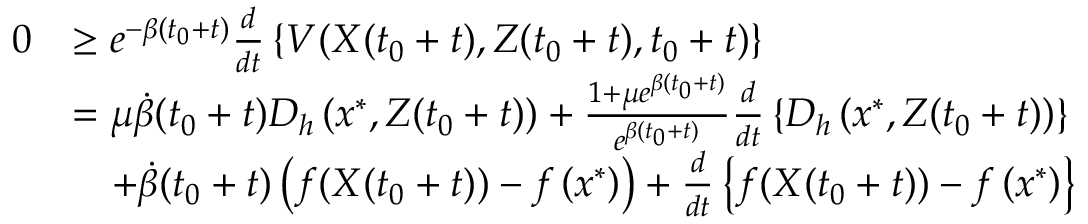<formula> <loc_0><loc_0><loc_500><loc_500>\begin{array} { r l } { 0 } & { \geq e ^ { - \beta ( t _ { 0 } + t ) } \frac { d } { d t } \left \{ V ( X ( t _ { 0 } + t ) , Z ( t _ { 0 } + t ) , t _ { 0 } + t ) \right \} } \\ & { = \mu \dot { \beta } ( t _ { 0 } + t ) D _ { h } \left ( x ^ { * } , Z ( t _ { 0 } + t ) \right ) + \frac { 1 + \mu e ^ { \beta ( t _ { 0 } + t ) } } { e ^ { \beta ( t _ { 0 } + t ) } } \frac { d } { d t } \left \{ D _ { h } \left ( x ^ { * } , Z ( t _ { 0 } + t ) \right ) \right \} } \\ & { \quad + \dot { \beta } ( t _ { 0 } + t ) \left ( f ( X ( t _ { 0 } + t ) ) - f \left ( x ^ { * } \right ) \right ) + \frac { d } { d t } \left \{ f ( X ( t _ { 0 } + t ) ) - f \left ( x ^ { * } \right ) \right \} } \end{array}</formula> 